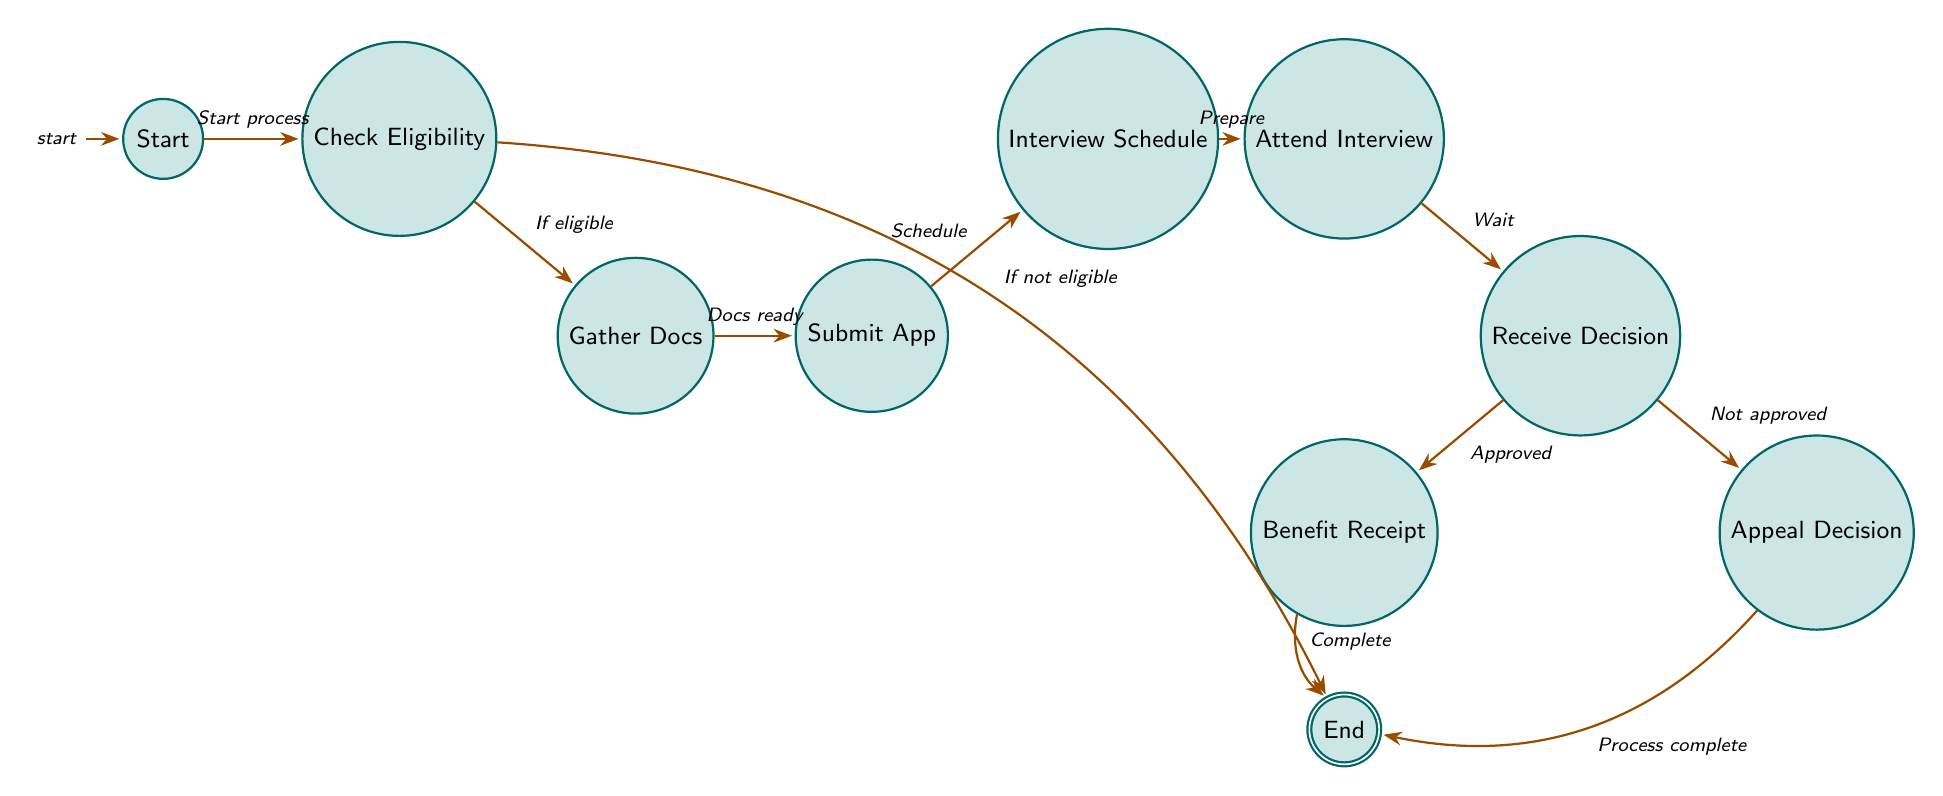What is the initial state of the process? The diagram starts with the "Start" state as indicated in the initial node of the finite state machine.
Answer: Start How many states are present in the diagram? Counting all the nodes in the diagram shows there are ten states: Start, Check Eligibility, Gather Documentation, Submit Application, Interview Schedule, Attend Interview, Receive Decision, Benefit Receipt, Appeal Decision, and End.
Answer: Ten What is the next state after "Check Eligibility" if the family is eligible? According to the transition from "Check Eligibility," if the family is eligible, the process moves to the "Gather Documentation" state.
Answer: Gather Documentation Which two states are connected by the transition "Schedule"? The transition labeled "Schedule" connects the states "Submit Application" and "Interview Schedule," indicating the action taken to move from application submission to scheduling the interview.
Answer: Submit Application and Interview Schedule What happens after the "Receive Decision" state if the application is not approved? Following the "Receive Decision" state, if the application is not approved, the process goes to the "Appeal Decision" state as indicated in the diagram.
Answer: Appeal Decision Which state concludes the process if the benefits are approved? If benefits are approved, the "Benefit Receipt" state is reached, which leads to the "End" state, indicating the successful conclusion of the process.
Answer: End What is the relationship between "Attend Interview" and "Receive Decision"? The transition from "Attend Interview" to "Receive Decision" indicates that after attending the interview, the next step is to wait for and receive a decision regarding the application.
Answer: Attend Interview leads to Receive Decision In which state do families begin receiving SNAP benefits? Families begin receiving SNAP benefits in the "Benefit Receipt" state, which follows the "Receive Decision" state if the decision was favorable.
Answer: Benefit Receipt 